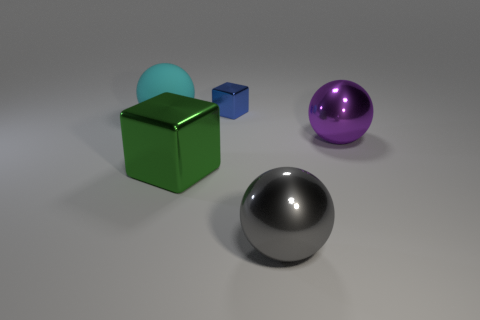How many balls are either big cyan things or tiny things?
Offer a terse response. 1. Is there a green metal thing of the same shape as the big gray metallic object?
Make the answer very short. No. The large gray metal thing is what shape?
Offer a terse response. Sphere. What number of things are either small metallic cylinders or large matte balls?
Provide a succinct answer. 1. There is a metal sphere that is behind the large shiny block; is it the same size as the ball left of the blue shiny thing?
Make the answer very short. Yes. How many other objects are there of the same material as the small blue object?
Provide a short and direct response. 3. Are there more large cubes on the left side of the purple sphere than purple objects that are on the left side of the large cyan thing?
Give a very brief answer. Yes. There is a large sphere that is to the right of the large gray object; what material is it?
Give a very brief answer. Metal. Does the large green metal thing have the same shape as the large cyan matte thing?
Offer a terse response. No. Is there any other thing that has the same color as the tiny cube?
Give a very brief answer. No. 